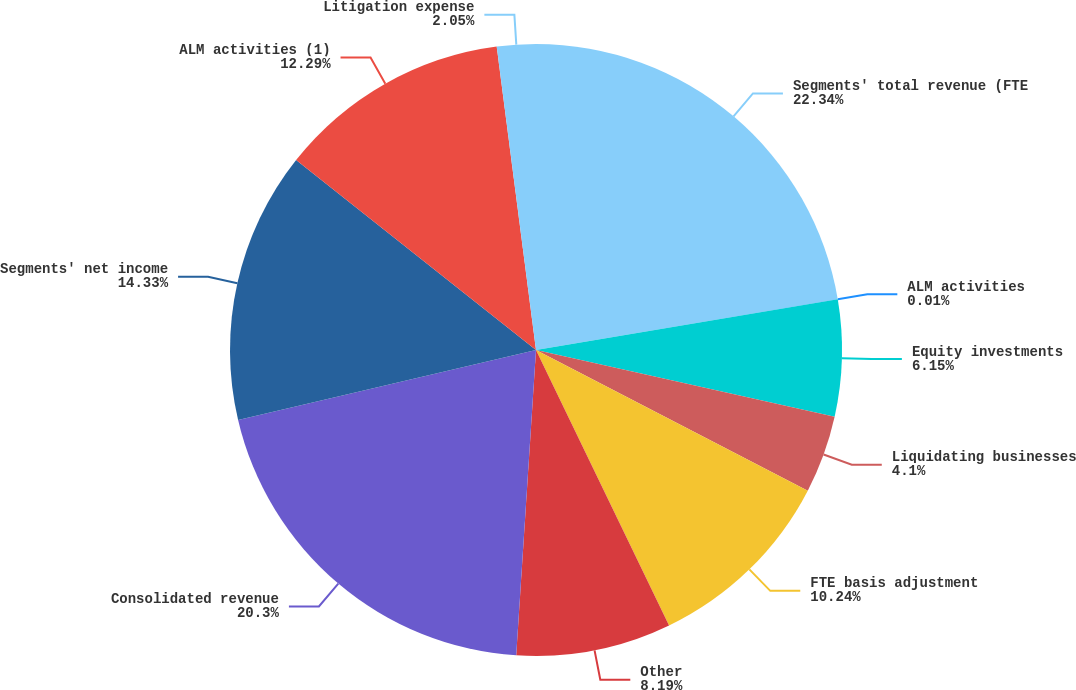<chart> <loc_0><loc_0><loc_500><loc_500><pie_chart><fcel>Segments' total revenue (FTE<fcel>ALM activities<fcel>Equity investments<fcel>Liquidating businesses<fcel>FTE basis adjustment<fcel>Other<fcel>Consolidated revenue<fcel>Segments' net income<fcel>ALM activities (1)<fcel>Litigation expense<nl><fcel>22.34%<fcel>0.01%<fcel>6.15%<fcel>4.1%<fcel>10.24%<fcel>8.19%<fcel>20.3%<fcel>14.33%<fcel>12.29%<fcel>2.05%<nl></chart> 